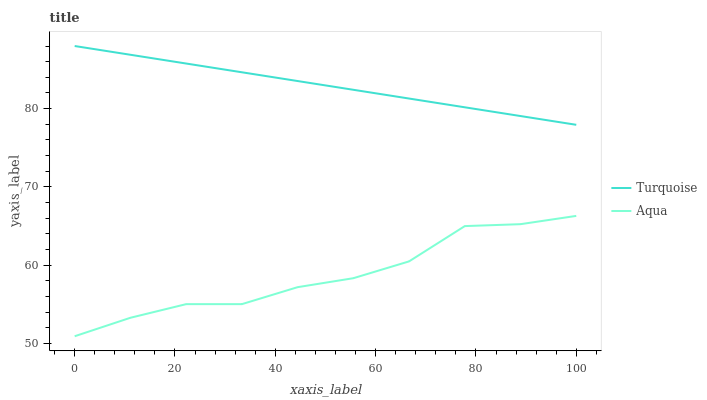Does Aqua have the maximum area under the curve?
Answer yes or no. No. Is Aqua the smoothest?
Answer yes or no. No. Does Aqua have the highest value?
Answer yes or no. No. Is Aqua less than Turquoise?
Answer yes or no. Yes. Is Turquoise greater than Aqua?
Answer yes or no. Yes. Does Aqua intersect Turquoise?
Answer yes or no. No. 